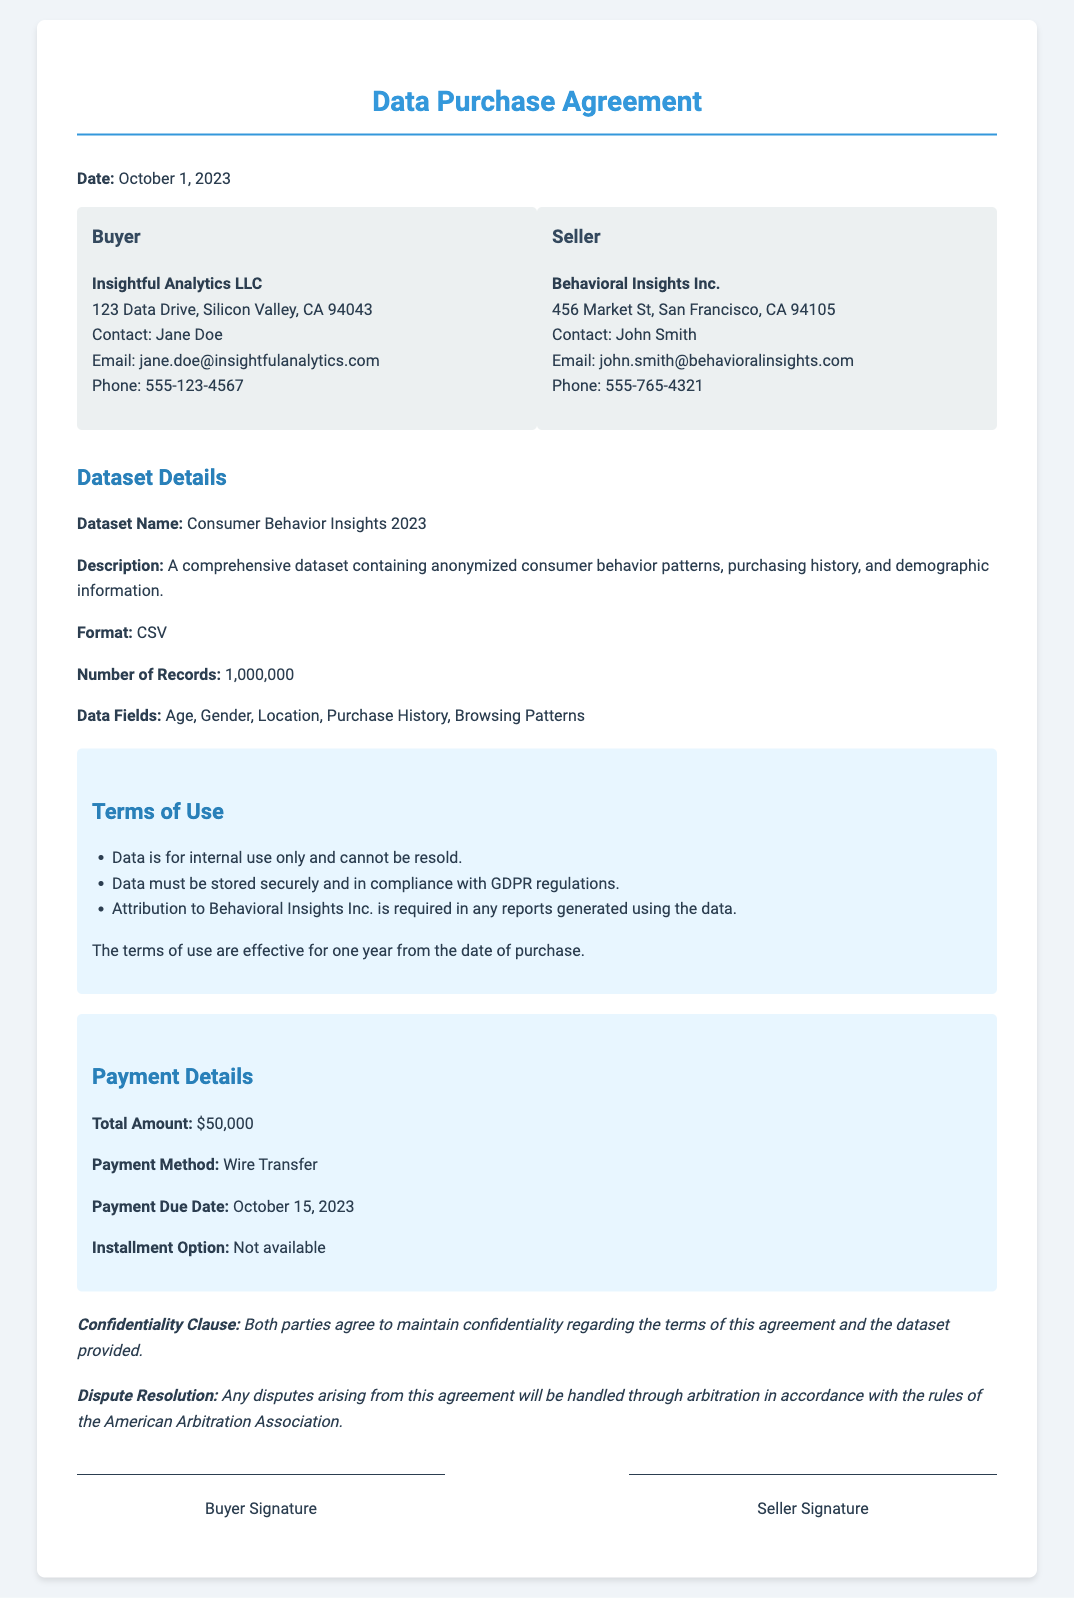What is the date of the agreement? The date of the agreement is stated at the top of the document.
Answer: October 1, 2023 Who is the buyer? The buyer is identified in the party section of the document.
Answer: Insightful Analytics LLC What is the total amount to be paid? The total payment amount is clearly outlined in the payment details section.
Answer: $50,000 What is the payment due date? The payment due date is specified in the payment details section.
Answer: October 15, 2023 What is the format of the dataset? The format of the dataset is stated in the dataset details section of the document.
Answer: CSV How many records are included in the dataset? The number of records in the dataset is provided in the dataset details section.
Answer: 1,000,000 What is required for attribution in reports? The attribution requirement is mentioned in the terms of use section.
Answer: Attribution to Behavioral Insights Inc What type of disputes are mentioned in the document? The type of dispute resolution is described towards the end of the document.
Answer: Arbitration Is there an installment option for payment? The details regarding the payment options are included in the payment section.
Answer: Not available 